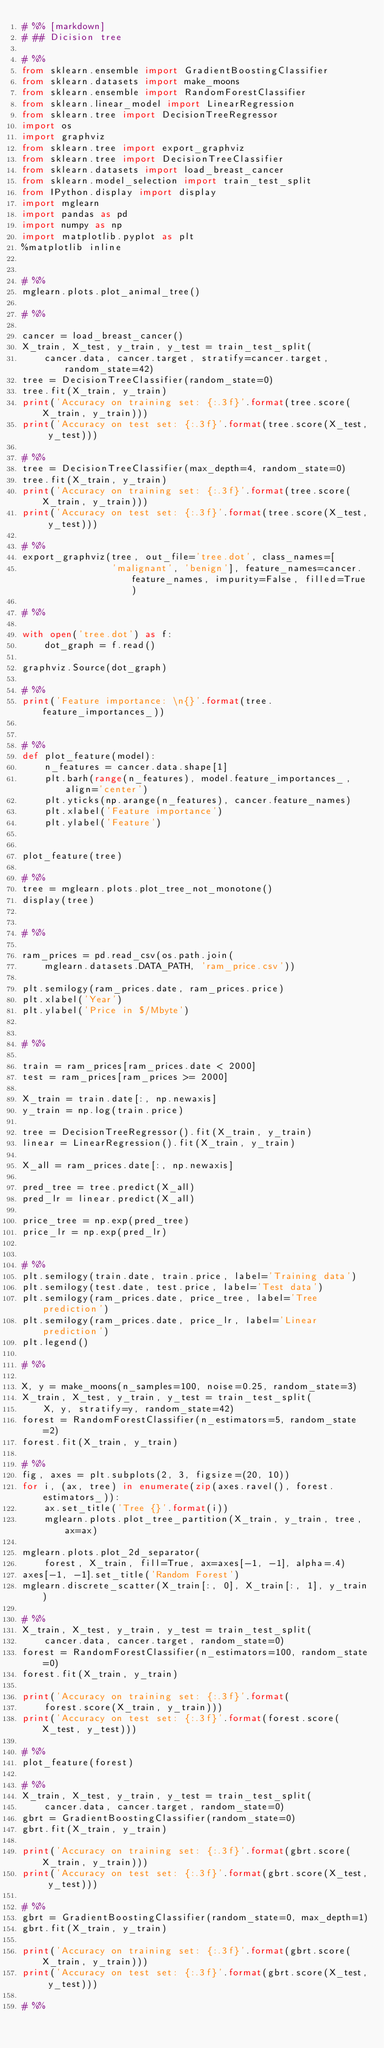<code> <loc_0><loc_0><loc_500><loc_500><_Python_># %% [markdown]
# ## Dicision tree

# %%
from sklearn.ensemble import GradientBoostingClassifier
from sklearn.datasets import make_moons
from sklearn.ensemble import RandomForestClassifier
from sklearn.linear_model import LinearRegression
from sklearn.tree import DecisionTreeRegressor
import os
import graphviz
from sklearn.tree import export_graphviz
from sklearn.tree import DecisionTreeClassifier
from sklearn.datasets import load_breast_cancer
from sklearn.model_selection import train_test_split
from IPython.display import display
import mglearn
import pandas as pd
import numpy as np
import matplotlib.pyplot as plt
%matplotlib inline


# %%
mglearn.plots.plot_animal_tree()

# %%

cancer = load_breast_cancer()
X_train, X_test, y_train, y_test = train_test_split(
    cancer.data, cancer.target, stratify=cancer.target, random_state=42)
tree = DecisionTreeClassifier(random_state=0)
tree.fit(X_train, y_train)
print('Accuracy on training set: {:.3f}'.format(tree.score(X_train, y_train)))
print('Accuracy on test set: {:.3f}'.format(tree.score(X_test, y_test)))

# %%
tree = DecisionTreeClassifier(max_depth=4, random_state=0)
tree.fit(X_train, y_train)
print('Accuracy on training set: {:.3f}'.format(tree.score(X_train, y_train)))
print('Accuracy on test set: {:.3f}'.format(tree.score(X_test, y_test)))

# %%
export_graphviz(tree, out_file='tree.dot', class_names=[
                'malignant', 'benign'], feature_names=cancer.feature_names, impurity=False, filled=True)

# %%

with open('tree.dot') as f:
    dot_graph = f.read()

graphviz.Source(dot_graph)

# %%
print('Feature importance: \n{}'.format(tree.feature_importances_))


# %%
def plot_feature(model):
    n_features = cancer.data.shape[1]
    plt.barh(range(n_features), model.feature_importances_, align='center')
    plt.yticks(np.arange(n_features), cancer.feature_names)
    plt.xlabel('Feature importance')
    plt.ylabel('Feature')


plot_feature(tree)

# %%
tree = mglearn.plots.plot_tree_not_monotone()
display(tree)


# %%

ram_prices = pd.read_csv(os.path.join(
    mglearn.datasets.DATA_PATH, 'ram_price.csv'))

plt.semilogy(ram_prices.date, ram_prices.price)
plt.xlabel('Year')
plt.ylabel('Price in $/Mbyte')


# %%

train = ram_prices[ram_prices.date < 2000]
test = ram_prices[ram_prices >= 2000]

X_train = train.date[:, np.newaxis]
y_train = np.log(train.price)

tree = DecisionTreeRegressor().fit(X_train, y_train)
linear = LinearRegression().fit(X_train, y_train)

X_all = ram_prices.date[:, np.newaxis]

pred_tree = tree.predict(X_all)
pred_lr = linear.predict(X_all)

price_tree = np.exp(pred_tree)
price_lr = np.exp(pred_lr)


# %%
plt.semilogy(train.date, train.price, label='Training data')
plt.semilogy(test.date, test.price, label='Test data')
plt.semilogy(ram_prices.date, price_tree, label='Tree prediction')
plt.semilogy(ram_prices.date, price_lr, label='Linear prediction')
plt.legend()

# %%

X, y = make_moons(n_samples=100, noise=0.25, random_state=3)
X_train, X_test, y_train, y_test = train_test_split(
    X, y, stratify=y, random_state=42)
forest = RandomForestClassifier(n_estimators=5, random_state=2)
forest.fit(X_train, y_train)

# %%
fig, axes = plt.subplots(2, 3, figsize=(20, 10))
for i, (ax, tree) in enumerate(zip(axes.ravel(), forest.estimators_)):
    ax.set_title('Tree {}'.format(i))
    mglearn.plots.plot_tree_partition(X_train, y_train, tree, ax=ax)

mglearn.plots.plot_2d_separator(
    forest, X_train, fill=True, ax=axes[-1, -1], alpha=.4)
axes[-1, -1].set_title('Random Forest')
mglearn.discrete_scatter(X_train[:, 0], X_train[:, 1], y_train)

# %%
X_train, X_test, y_train, y_test = train_test_split(
    cancer.data, cancer.target, random_state=0)
forest = RandomForestClassifier(n_estimators=100, random_state=0)
forest.fit(X_train, y_train)

print('Accuracy on training set: {:.3f}'.format(
    forest.score(X_train, y_train)))
print('Accuracy on test set: {:.3f}'.format(forest.score(X_test, y_test)))

# %%
plot_feature(forest)

# %%
X_train, X_test, y_train, y_test = train_test_split(
    cancer.data, cancer.target, random_state=0)
gbrt = GradientBoostingClassifier(random_state=0)
gbrt.fit(X_train, y_train)

print('Accuracy on training set: {:.3f}'.format(gbrt.score(X_train, y_train)))
print('Accuracy on test set: {:.3f}'.format(gbrt.score(X_test, y_test)))

# %%
gbrt = GradientBoostingClassifier(random_state=0, max_depth=1)
gbrt.fit(X_train, y_train)

print('Accuracy on training set: {:.3f}'.format(gbrt.score(X_train, y_train)))
print('Accuracy on test set: {:.3f}'.format(gbrt.score(X_test, y_test)))

# %%</code> 